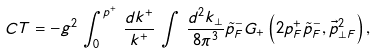Convert formula to latex. <formula><loc_0><loc_0><loc_500><loc_500>C T = - g ^ { 2 } \, \int _ { 0 } ^ { p ^ { + } } \, \frac { d k ^ { + } } { k ^ { + } } \, \int \, \frac { d ^ { 2 } k _ { \perp } } { 8 \pi ^ { 3 } } \tilde { p } ^ { - } _ { F } G _ { + } \left ( 2 p ^ { + } _ { F } \tilde { p } ^ { - } _ { F } , { \vec { p } } _ { \perp F } ^ { 2 } \right ) ,</formula> 